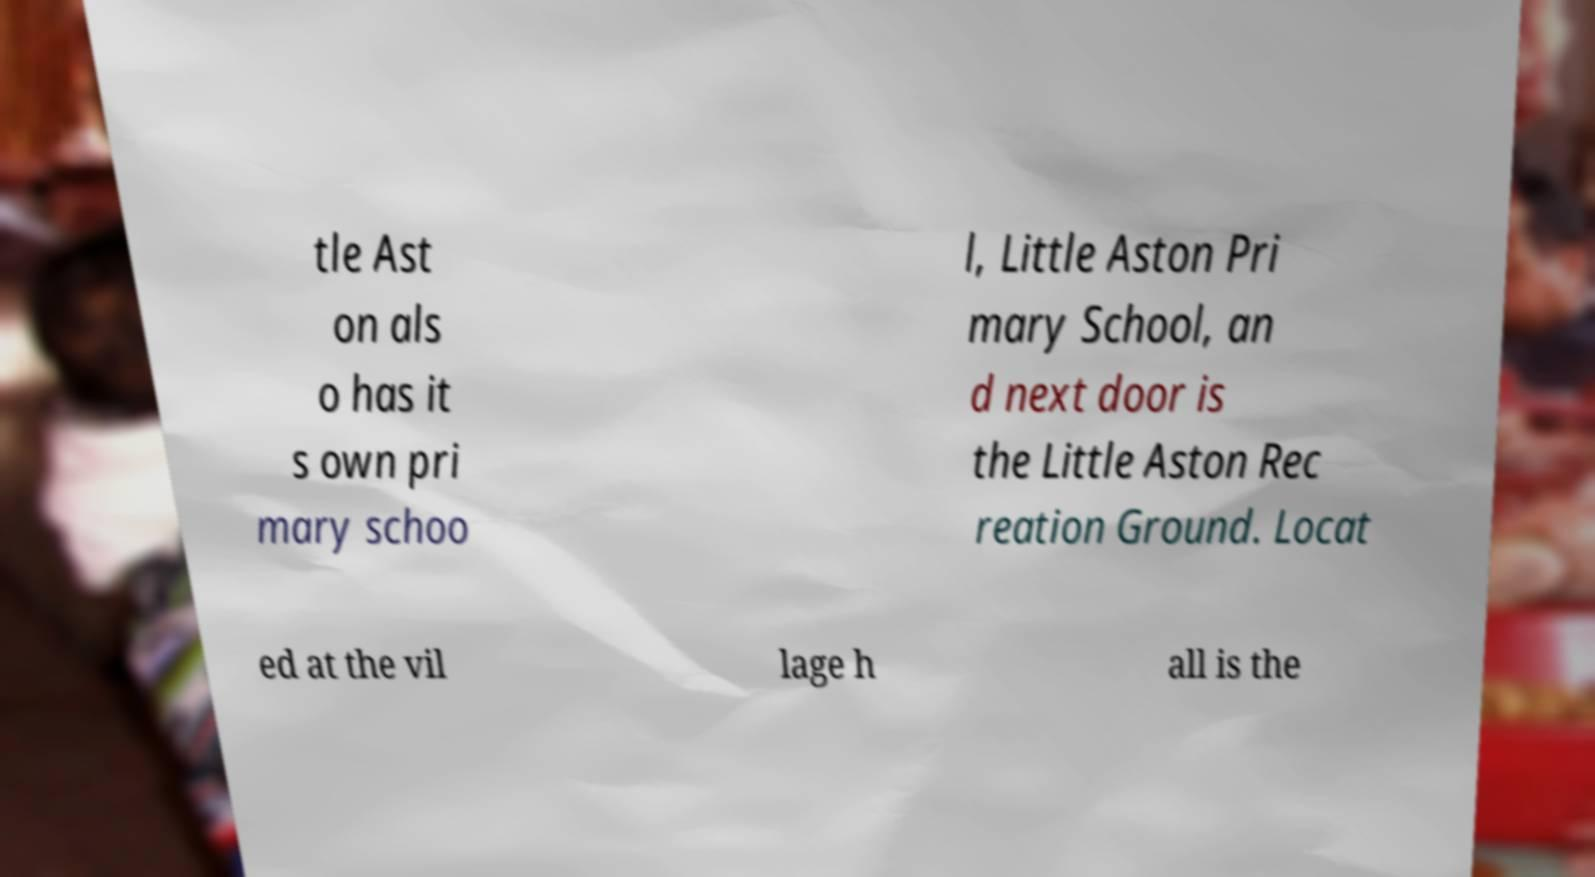What messages or text are displayed in this image? I need them in a readable, typed format. tle Ast on als o has it s own pri mary schoo l, Little Aston Pri mary School, an d next door is the Little Aston Rec reation Ground. Locat ed at the vil lage h all is the 